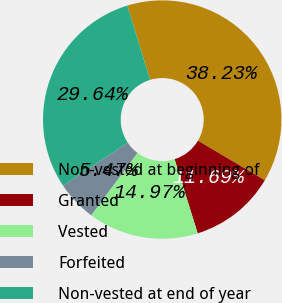<chart> <loc_0><loc_0><loc_500><loc_500><pie_chart><fcel>Non-vested at beginning of<fcel>Granted<fcel>Vested<fcel>Forfeited<fcel>Non-vested at end of year<nl><fcel>38.23%<fcel>11.69%<fcel>14.97%<fcel>5.47%<fcel>29.64%<nl></chart> 